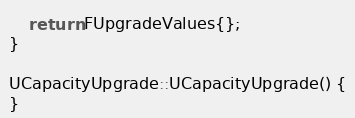Convert code to text. <code><loc_0><loc_0><loc_500><loc_500><_C++_>    return FUpgradeValues{};
}

UCapacityUpgrade::UCapacityUpgrade() {
}

</code> 